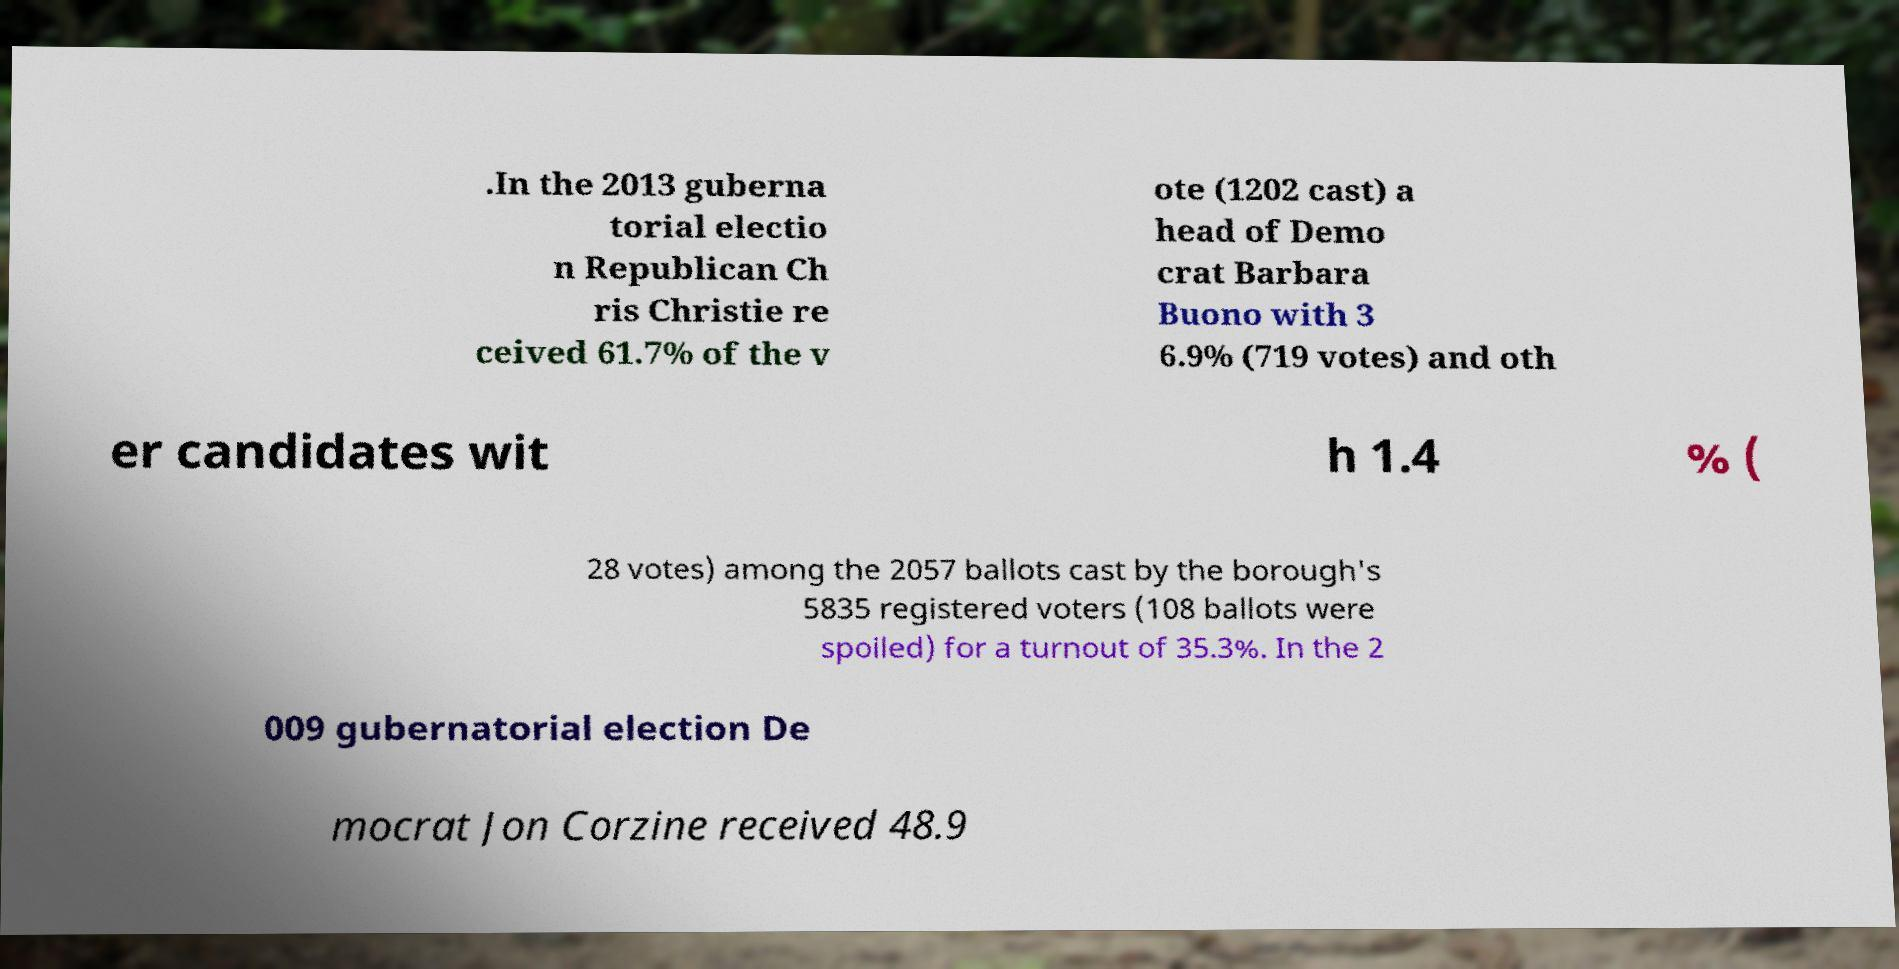Please identify and transcribe the text found in this image. .In the 2013 guberna torial electio n Republican Ch ris Christie re ceived 61.7% of the v ote (1202 cast) a head of Demo crat Barbara Buono with 3 6.9% (719 votes) and oth er candidates wit h 1.4 % ( 28 votes) among the 2057 ballots cast by the borough's 5835 registered voters (108 ballots were spoiled) for a turnout of 35.3%. In the 2 009 gubernatorial election De mocrat Jon Corzine received 48.9 